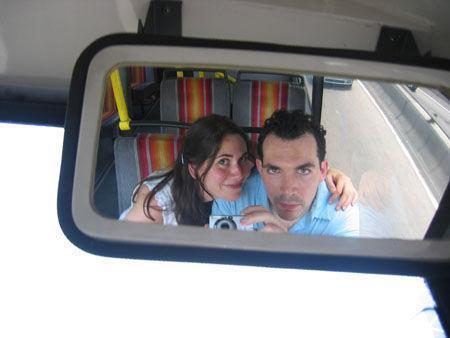How many people are pictured?
Give a very brief answer. 2. How many people are visible?
Give a very brief answer. 2. How many people are in the photo?
Give a very brief answer. 2. 